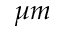<formula> <loc_0><loc_0><loc_500><loc_500>\mu m</formula> 